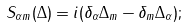Convert formula to latex. <formula><loc_0><loc_0><loc_500><loc_500>S _ { \alpha m } ( \Delta ) = i ( \delta _ { \alpha } \Delta _ { m } - \delta _ { m } \Delta _ { \alpha } ) ;</formula> 